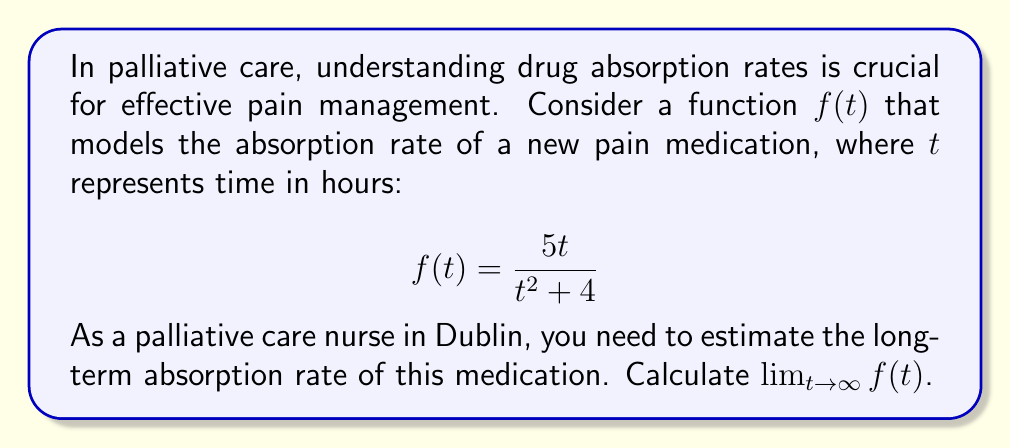Can you answer this question? To find the limit of $f(t)$ as $t$ approaches infinity, we can follow these steps:

1) First, let's examine the function:
   $$f(t) = \frac{5t}{t^2 + 4}$$

2) To find the limit as $t$ approaches infinity, we need to consider the behavior of the numerator and denominator separately as $t$ gets very large.

3) In the numerator, we have $5t$, which grows linearly with $t$.

4) In the denominator, we have $t^2 + 4$. As $t$ gets very large, the $t^2$ term will dominate, and the 4 will become negligible in comparison.

5) We can use the technique of dividing both numerator and denominator by the highest power of $t$ in the denominator, which is $t^2$:

   $$\lim_{t \to \infty} \frac{5t}{t^2 + 4} = \lim_{t \to \infty} \frac{5t/t^2}{(t^2 + 4)/t^2} = \lim_{t \to \infty} \frac{5/t}{1 + 4/t^2}$$

6) As $t$ approaches infinity:
   - $5/t$ approaches 0
   - $4/t^2$ approaches 0
   - So the denominator approaches 1

7) Therefore, the limit simplifies to:

   $$\lim_{t \to \infty} \frac{5/t}{1 + 4/t^2} = \frac{0}{1} = 0$$

This result indicates that the drug absorption rate approaches zero as time goes to infinity, which is consistent with the body's decreasing ability to absorb the medication over extended periods.
Answer: $\lim_{t \to \infty} f(t) = 0$ 